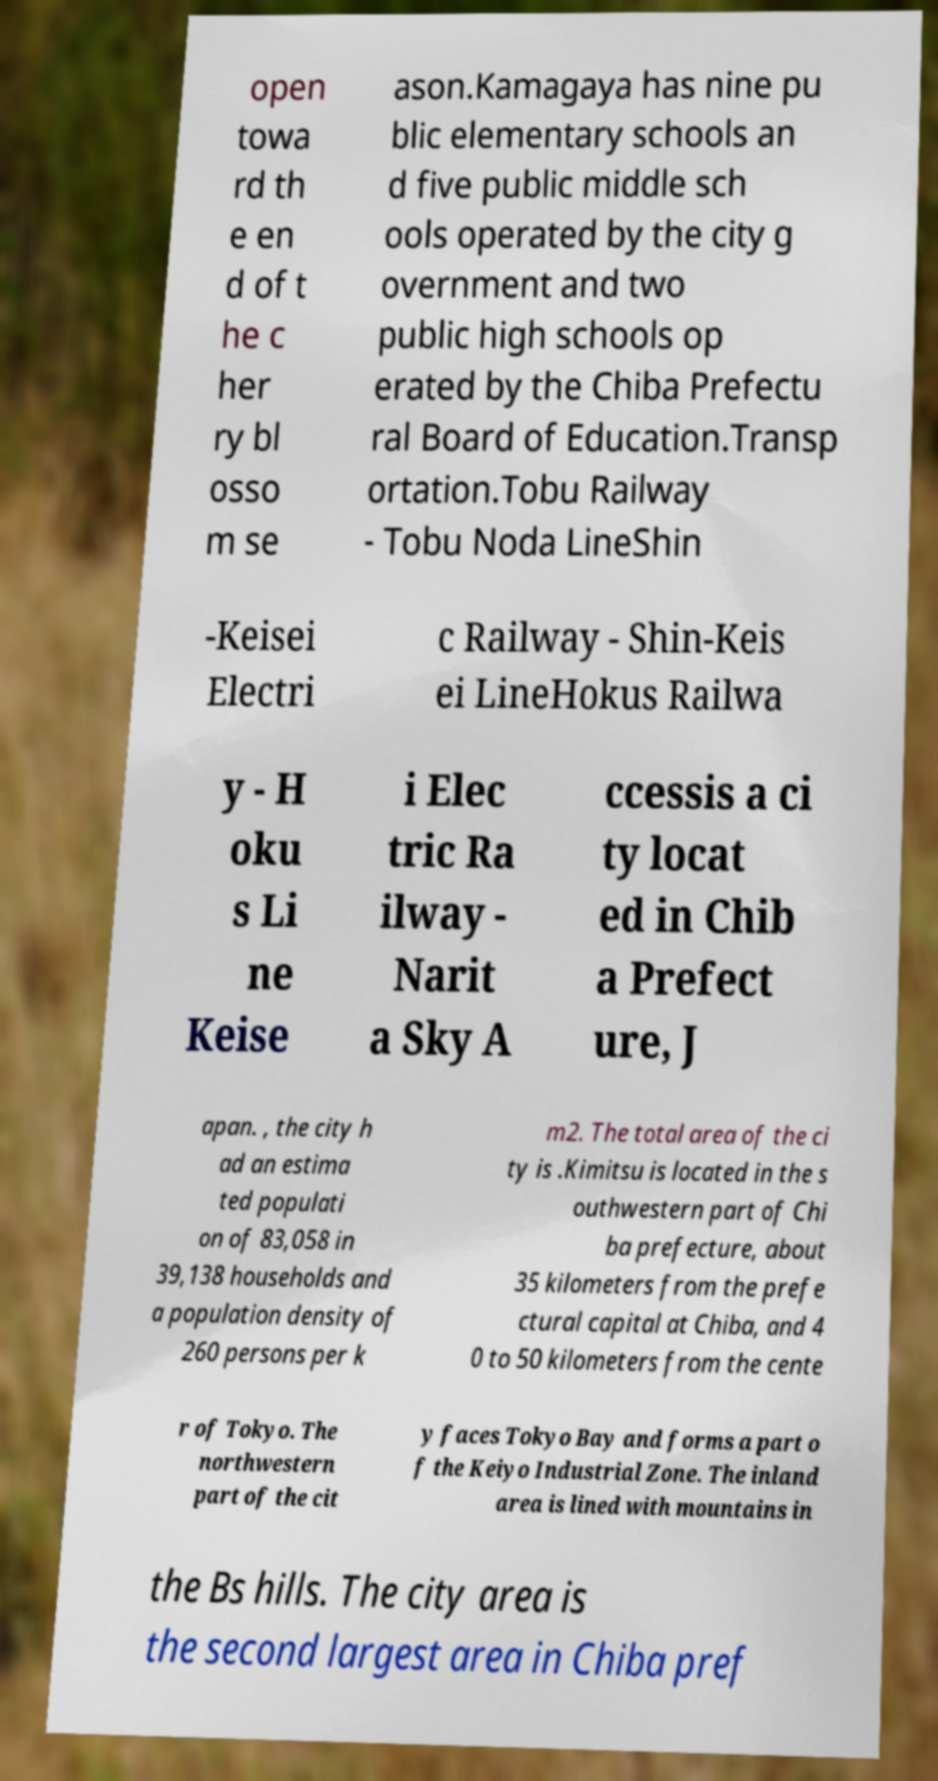Can you accurately transcribe the text from the provided image for me? open towa rd th e en d of t he c her ry bl osso m se ason.Kamagaya has nine pu blic elementary schools an d five public middle sch ools operated by the city g overnment and two public high schools op erated by the Chiba Prefectu ral Board of Education.Transp ortation.Tobu Railway - Tobu Noda LineShin -Keisei Electri c Railway - Shin-Keis ei LineHokus Railwa y - H oku s Li ne Keise i Elec tric Ra ilway - Narit a Sky A ccessis a ci ty locat ed in Chib a Prefect ure, J apan. , the city h ad an estima ted populati on of 83,058 in 39,138 households and a population density of 260 persons per k m2. The total area of the ci ty is .Kimitsu is located in the s outhwestern part of Chi ba prefecture, about 35 kilometers from the prefe ctural capital at Chiba, and 4 0 to 50 kilometers from the cente r of Tokyo. The northwestern part of the cit y faces Tokyo Bay and forms a part o f the Keiyo Industrial Zone. The inland area is lined with mountains in the Bs hills. The city area is the second largest area in Chiba pref 